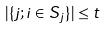Convert formula to latex. <formula><loc_0><loc_0><loc_500><loc_500>| \{ j ; i \in S _ { j } \} | \leq t</formula> 